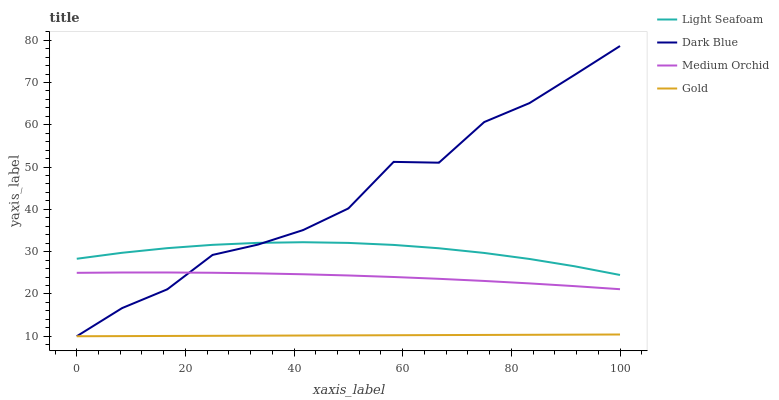Does Gold have the minimum area under the curve?
Answer yes or no. Yes. Does Dark Blue have the maximum area under the curve?
Answer yes or no. Yes. Does Medium Orchid have the minimum area under the curve?
Answer yes or no. No. Does Medium Orchid have the maximum area under the curve?
Answer yes or no. No. Is Gold the smoothest?
Answer yes or no. Yes. Is Dark Blue the roughest?
Answer yes or no. Yes. Is Medium Orchid the smoothest?
Answer yes or no. No. Is Medium Orchid the roughest?
Answer yes or no. No. Does Dark Blue have the lowest value?
Answer yes or no. Yes. Does Medium Orchid have the lowest value?
Answer yes or no. No. Does Dark Blue have the highest value?
Answer yes or no. Yes. Does Medium Orchid have the highest value?
Answer yes or no. No. Is Gold less than Light Seafoam?
Answer yes or no. Yes. Is Light Seafoam greater than Medium Orchid?
Answer yes or no. Yes. Does Gold intersect Dark Blue?
Answer yes or no. Yes. Is Gold less than Dark Blue?
Answer yes or no. No. Is Gold greater than Dark Blue?
Answer yes or no. No. Does Gold intersect Light Seafoam?
Answer yes or no. No. 